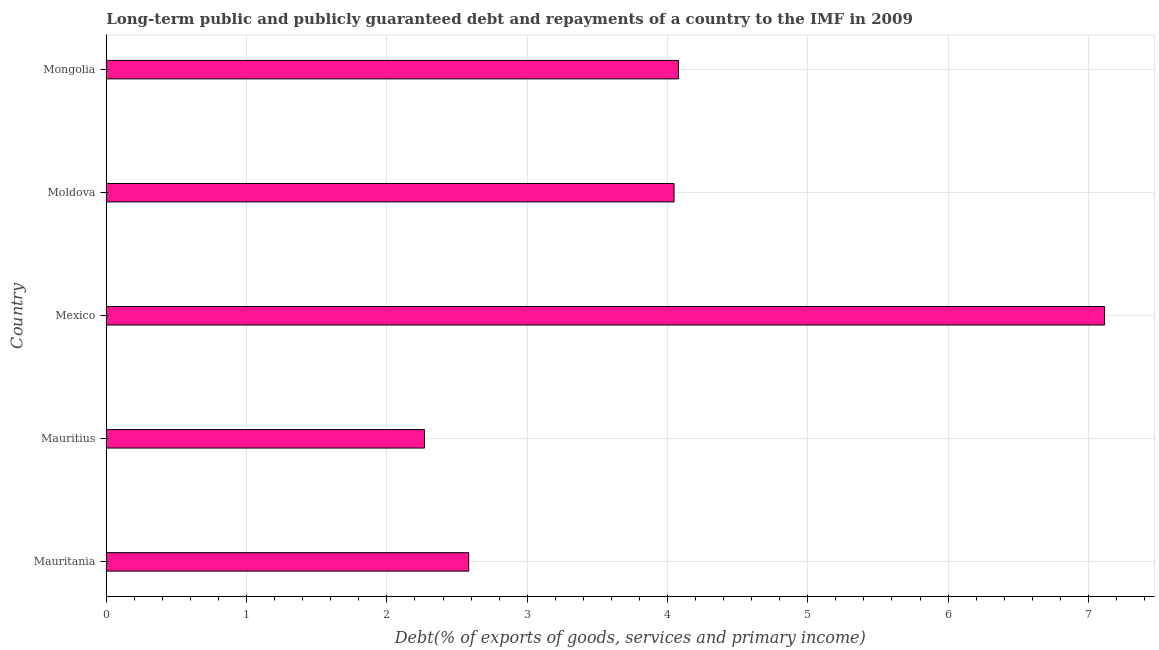What is the title of the graph?
Make the answer very short. Long-term public and publicly guaranteed debt and repayments of a country to the IMF in 2009. What is the label or title of the X-axis?
Your answer should be very brief. Debt(% of exports of goods, services and primary income). What is the debt service in Mauritania?
Provide a succinct answer. 2.58. Across all countries, what is the maximum debt service?
Your answer should be very brief. 7.12. Across all countries, what is the minimum debt service?
Provide a succinct answer. 2.27. In which country was the debt service minimum?
Ensure brevity in your answer.  Mauritius. What is the sum of the debt service?
Offer a terse response. 20.09. What is the difference between the debt service in Mauritius and Mexico?
Your response must be concise. -4.85. What is the average debt service per country?
Your response must be concise. 4.02. What is the median debt service?
Your answer should be very brief. 4.05. In how many countries, is the debt service greater than 2.4 %?
Offer a very short reply. 4. What is the ratio of the debt service in Mauritania to that in Mauritius?
Provide a short and direct response. 1.14. What is the difference between the highest and the second highest debt service?
Give a very brief answer. 3.04. What is the difference between the highest and the lowest debt service?
Make the answer very short. 4.85. In how many countries, is the debt service greater than the average debt service taken over all countries?
Make the answer very short. 3. How many bars are there?
Provide a short and direct response. 5. Are all the bars in the graph horizontal?
Your response must be concise. Yes. How many countries are there in the graph?
Offer a terse response. 5. What is the Debt(% of exports of goods, services and primary income) in Mauritania?
Keep it short and to the point. 2.58. What is the Debt(% of exports of goods, services and primary income) in Mauritius?
Ensure brevity in your answer.  2.27. What is the Debt(% of exports of goods, services and primary income) in Mexico?
Your answer should be very brief. 7.12. What is the Debt(% of exports of goods, services and primary income) in Moldova?
Ensure brevity in your answer.  4.05. What is the Debt(% of exports of goods, services and primary income) in Mongolia?
Ensure brevity in your answer.  4.08. What is the difference between the Debt(% of exports of goods, services and primary income) in Mauritania and Mauritius?
Make the answer very short. 0.31. What is the difference between the Debt(% of exports of goods, services and primary income) in Mauritania and Mexico?
Offer a terse response. -4.53. What is the difference between the Debt(% of exports of goods, services and primary income) in Mauritania and Moldova?
Provide a succinct answer. -1.46. What is the difference between the Debt(% of exports of goods, services and primary income) in Mauritania and Mongolia?
Make the answer very short. -1.49. What is the difference between the Debt(% of exports of goods, services and primary income) in Mauritius and Mexico?
Ensure brevity in your answer.  -4.85. What is the difference between the Debt(% of exports of goods, services and primary income) in Mauritius and Moldova?
Offer a terse response. -1.78. What is the difference between the Debt(% of exports of goods, services and primary income) in Mauritius and Mongolia?
Your answer should be compact. -1.81. What is the difference between the Debt(% of exports of goods, services and primary income) in Mexico and Moldova?
Give a very brief answer. 3.07. What is the difference between the Debt(% of exports of goods, services and primary income) in Mexico and Mongolia?
Your answer should be compact. 3.04. What is the difference between the Debt(% of exports of goods, services and primary income) in Moldova and Mongolia?
Offer a terse response. -0.03. What is the ratio of the Debt(% of exports of goods, services and primary income) in Mauritania to that in Mauritius?
Offer a terse response. 1.14. What is the ratio of the Debt(% of exports of goods, services and primary income) in Mauritania to that in Mexico?
Ensure brevity in your answer.  0.36. What is the ratio of the Debt(% of exports of goods, services and primary income) in Mauritania to that in Moldova?
Your answer should be very brief. 0.64. What is the ratio of the Debt(% of exports of goods, services and primary income) in Mauritania to that in Mongolia?
Your answer should be very brief. 0.63. What is the ratio of the Debt(% of exports of goods, services and primary income) in Mauritius to that in Mexico?
Offer a very short reply. 0.32. What is the ratio of the Debt(% of exports of goods, services and primary income) in Mauritius to that in Moldova?
Give a very brief answer. 0.56. What is the ratio of the Debt(% of exports of goods, services and primary income) in Mauritius to that in Mongolia?
Your answer should be very brief. 0.56. What is the ratio of the Debt(% of exports of goods, services and primary income) in Mexico to that in Moldova?
Provide a succinct answer. 1.76. What is the ratio of the Debt(% of exports of goods, services and primary income) in Mexico to that in Mongolia?
Make the answer very short. 1.75. What is the ratio of the Debt(% of exports of goods, services and primary income) in Moldova to that in Mongolia?
Provide a short and direct response. 0.99. 